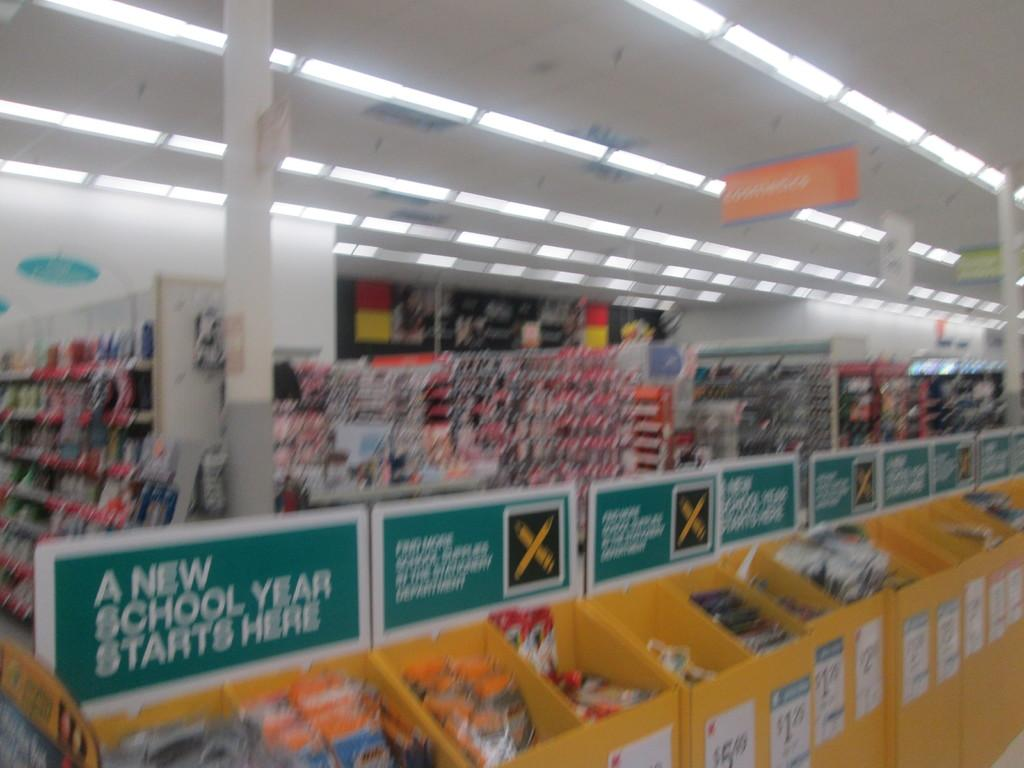What type of establishment is shown in the picture? There is a supermarket in the picture. How are the items organized in the supermarket? The items are placed in the racks in the supermarket. What is present in the ceiling of the supermarket? There are lights and boards in the ceiling of the supermarket. Reasoning: Let' Let's think step by step in order to produce the conversation. We start by identifying the main subject of the image, which is the supermarket. Then, we describe how the items are organized within the supermarket, focusing on the racks. Finally, we mention the features present in the ceiling, specifically the lights and boards. Each question is designed to elicit a specific detail about the image that is known from the provided facts. Absurd Question/Answer: What type of plant is growing on the cord in the image? There is no plant growing on a cord in the image, as the focus is on the supermarket and its features. What type of plant is growing on the cord in the image? There is no plant growing on a cord in the image, as the focus is on the supermarket and its features. 